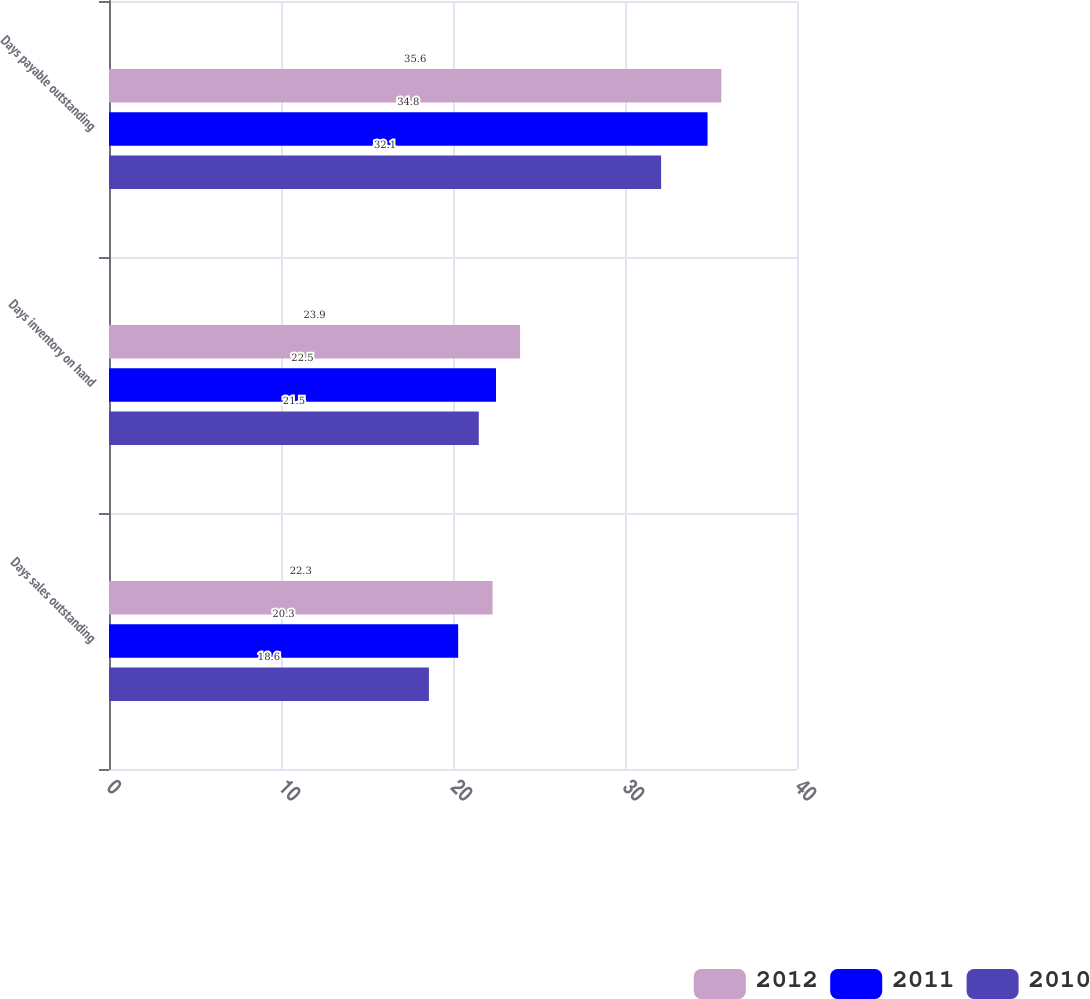Convert chart. <chart><loc_0><loc_0><loc_500><loc_500><stacked_bar_chart><ecel><fcel>Days sales outstanding<fcel>Days inventory on hand<fcel>Days payable outstanding<nl><fcel>2012<fcel>22.3<fcel>23.9<fcel>35.6<nl><fcel>2011<fcel>20.3<fcel>22.5<fcel>34.8<nl><fcel>2010<fcel>18.6<fcel>21.5<fcel>32.1<nl></chart> 